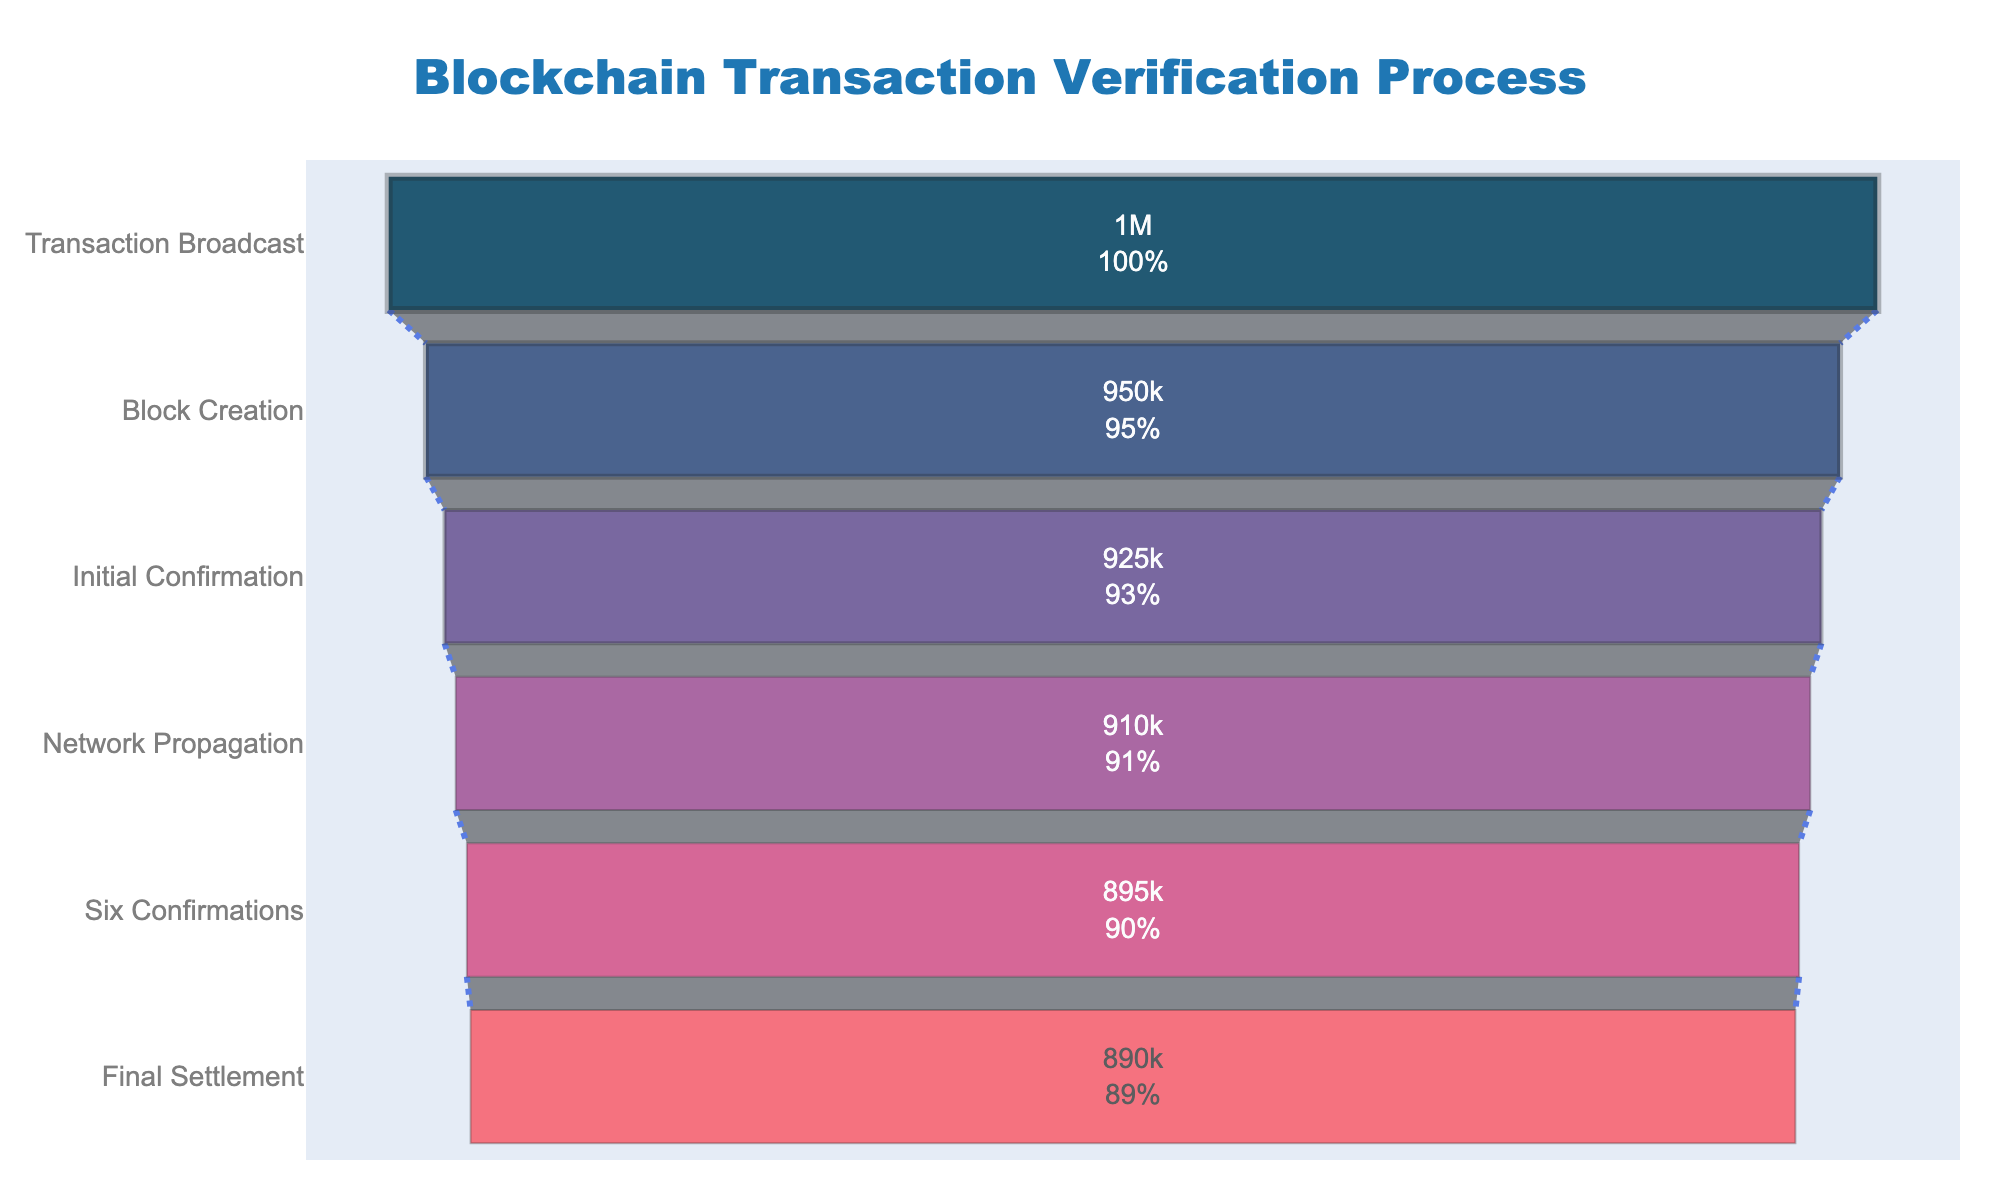What is the title of the funnel chart? The chart's title is displayed at the top center of the figure. By looking at this section, the title of this funnel chart can be seen.
Answer: Blockchain Transaction Verification Process How many stages are there in the blockchain transaction verification process shown in the funnel chart? The number of stages can be determined by counting the different unique stages in the funnel chart.
Answer: 6 What is the total number of transactions at the "Final Settlement" stage? The funnel chart displays the number of transactions at each stage inside the corresponding sections. For "Final Settlement," the value shown is the required answer.
Answer: 890,000 Which stage has the smallest number of transactions? By comparing the number of transactions displayed for each stage, you can identify the stage with the smallest number.
Answer: Final Settlement What is the difference in transactions between "Transaction Broadcast" and "Initial Confirmation"? To find the difference, subtract the number of transactions in the "Initial Confirmation" stage from the "Transaction Broadcast" stage: 1,000,000 - 925,000.
Answer: 75,000 What percentage of transactions are confirmed by the "Six Confirmations" stage? The percentage of transactions can be identified by the percentage label in the "Six Confirmations" section.
Answer: 89.5% How many transactions are lost between "Network Propagation" and "Six Confirmations"? To calculate the transaction drop, subtract the number of transactions at "Six Confirmations" from those at "Network Propagation": 910,000 - 895,000.
Answer: 15,000 Which stage sees the greatest drop in the number of transactions? Compare the drop in the number of transactions between each consecutive pair of stages by subtraction: the stage with the highest drop is the one of interest.
Answer: Transaction Broadcast to Block Creation What percentage of transactions initially broadcast are successfully finalized in the "Final Settlement" stage? The percentage of transactions finalized is calculated by the ratio of "Final Settlement" to "Transaction Broadcast" multiplied by 100: (890,000 / 1,000,000) * 100.
Answer: 89% What are the colors used in the funnel chart for different stages? The colors for the different stages can be seen visually on the funnel segments. The order from top to bottom are the colors used.
Answer: #003f5c, #2f4b7c, #665191, #a05195, #d45087, #f95d6a 